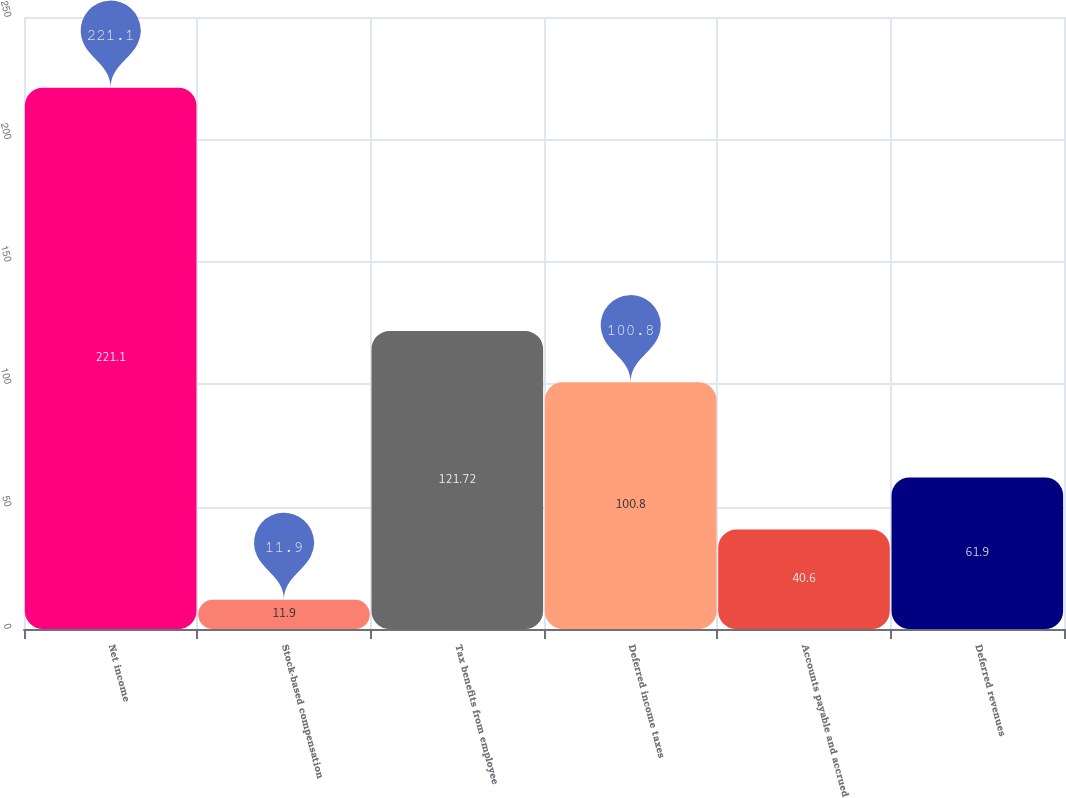Convert chart. <chart><loc_0><loc_0><loc_500><loc_500><bar_chart><fcel>Net income<fcel>Stock-based compensation<fcel>Tax benefits from employee<fcel>Deferred income taxes<fcel>Accounts payable and accrued<fcel>Deferred revenues<nl><fcel>221.1<fcel>11.9<fcel>121.72<fcel>100.8<fcel>40.6<fcel>61.9<nl></chart> 